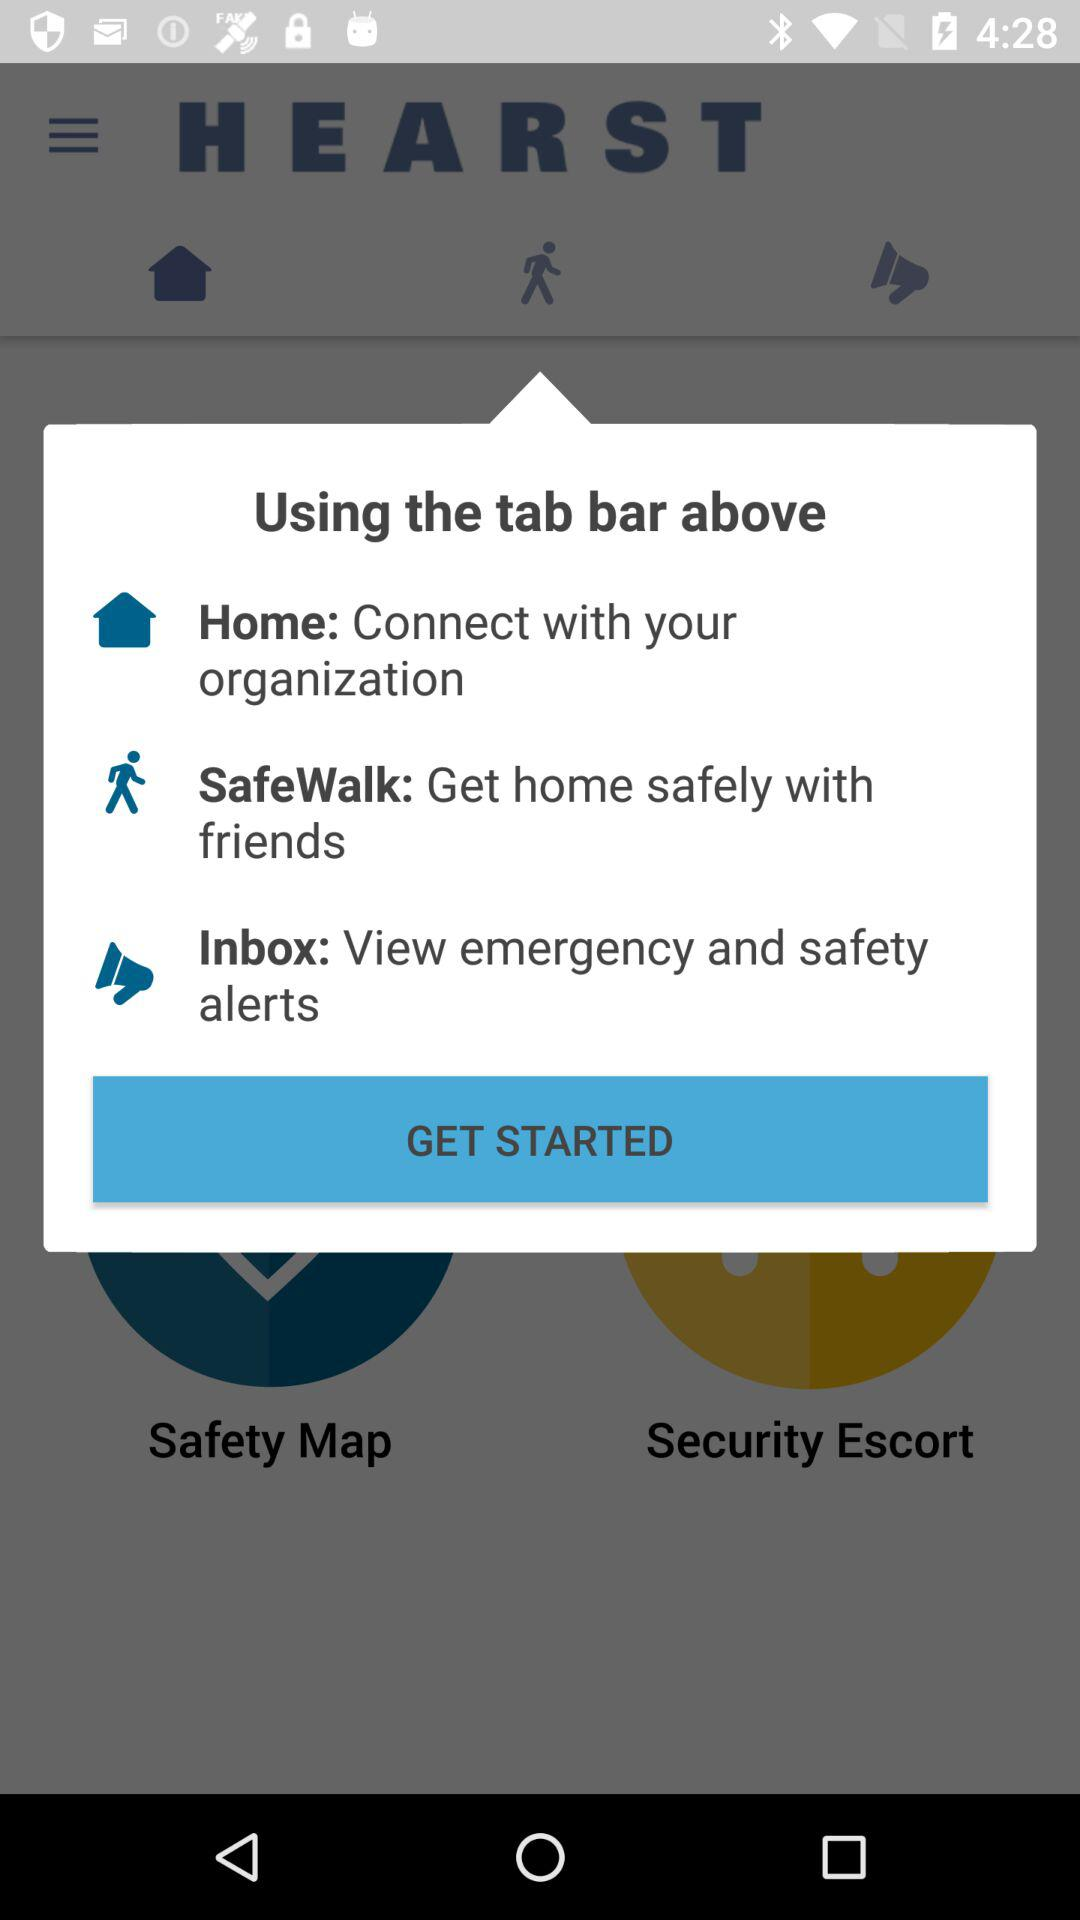What is the description given for "SafeWalk"? The description is "Get home safely with friends". 